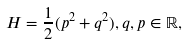<formula> <loc_0><loc_0><loc_500><loc_500>H = \frac { 1 } { 2 } ( p ^ { 2 } + q ^ { 2 } ) , q , p \in \mathbb { R } ,</formula> 